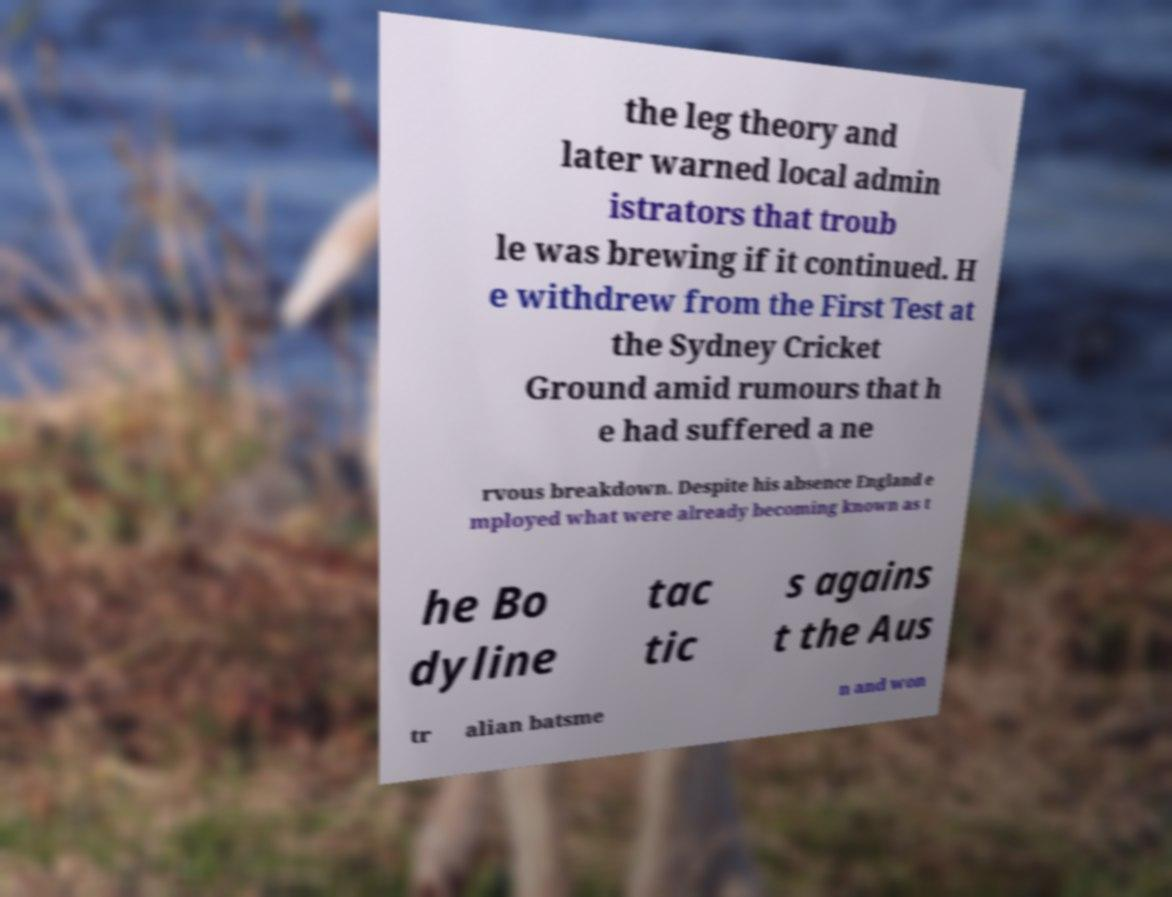For documentation purposes, I need the text within this image transcribed. Could you provide that? the leg theory and later warned local admin istrators that troub le was brewing if it continued. H e withdrew from the First Test at the Sydney Cricket Ground amid rumours that h e had suffered a ne rvous breakdown. Despite his absence England e mployed what were already becoming known as t he Bo dyline tac tic s agains t the Aus tr alian batsme n and won 